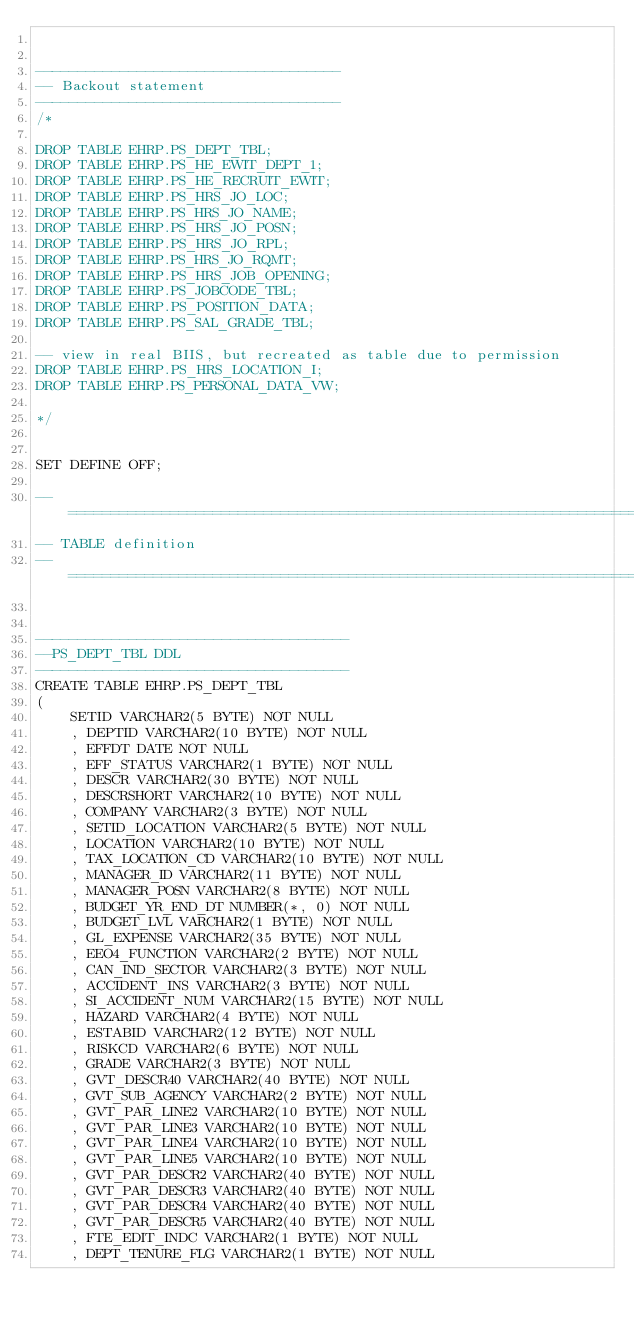<code> <loc_0><loc_0><loc_500><loc_500><_SQL_>

------------------------------------
-- Backout statement
------------------------------------
/*

DROP TABLE EHRP.PS_DEPT_TBL;
DROP TABLE EHRP.PS_HE_EWIT_DEPT_1;
DROP TABLE EHRP.PS_HE_RECRUIT_EWIT;
DROP TABLE EHRP.PS_HRS_JO_LOC;
DROP TABLE EHRP.PS_HRS_JO_NAME;
DROP TABLE EHRP.PS_HRS_JO_POSN;
DROP TABLE EHRP.PS_HRS_JO_RPL;
DROP TABLE EHRP.PS_HRS_JO_RQMT;
DROP TABLE EHRP.PS_HRS_JOB_OPENING;
DROP TABLE EHRP.PS_JOBCODE_TBL;
DROP TABLE EHRP.PS_POSITION_DATA;
DROP TABLE EHRP.PS_SAL_GRADE_TBL;

-- view in real BIIS, but recreated as table due to permission
DROP TABLE EHRP.PS_HRS_LOCATION_I;
DROP TABLE EHRP.PS_PERSONAL_DATA_VW;

*/


SET DEFINE OFF;

--=============================================================================
-- TABLE definition
--=============================================================================


-------------------------------------
--PS_DEPT_TBL DDL
-------------------------------------
CREATE TABLE EHRP.PS_DEPT_TBL 
(
	SETID VARCHAR2(5 BYTE) NOT NULL 
	, DEPTID VARCHAR2(10 BYTE) NOT NULL 
	, EFFDT DATE NOT NULL 
	, EFF_STATUS VARCHAR2(1 BYTE) NOT NULL 
	, DESCR VARCHAR2(30 BYTE) NOT NULL 
	, DESCRSHORT VARCHAR2(10 BYTE) NOT NULL 
	, COMPANY VARCHAR2(3 BYTE) NOT NULL 
	, SETID_LOCATION VARCHAR2(5 BYTE) NOT NULL 
	, LOCATION VARCHAR2(10 BYTE) NOT NULL 
	, TAX_LOCATION_CD VARCHAR2(10 BYTE) NOT NULL 
	, MANAGER_ID VARCHAR2(11 BYTE) NOT NULL 
	, MANAGER_POSN VARCHAR2(8 BYTE) NOT NULL 
	, BUDGET_YR_END_DT NUMBER(*, 0) NOT NULL 
	, BUDGET_LVL VARCHAR2(1 BYTE) NOT NULL 
	, GL_EXPENSE VARCHAR2(35 BYTE) NOT NULL 
	, EEO4_FUNCTION VARCHAR2(2 BYTE) NOT NULL 
	, CAN_IND_SECTOR VARCHAR2(3 BYTE) NOT NULL 
	, ACCIDENT_INS VARCHAR2(3 BYTE) NOT NULL 
	, SI_ACCIDENT_NUM VARCHAR2(15 BYTE) NOT NULL 
	, HAZARD VARCHAR2(4 BYTE) NOT NULL 
	, ESTABID VARCHAR2(12 BYTE) NOT NULL 
	, RISKCD VARCHAR2(6 BYTE) NOT NULL 
	, GRADE VARCHAR2(3 BYTE) NOT NULL 
	, GVT_DESCR40 VARCHAR2(40 BYTE) NOT NULL 
	, GVT_SUB_AGENCY VARCHAR2(2 BYTE) NOT NULL 
	, GVT_PAR_LINE2 VARCHAR2(10 BYTE) NOT NULL 
	, GVT_PAR_LINE3 VARCHAR2(10 BYTE) NOT NULL 
	, GVT_PAR_LINE4 VARCHAR2(10 BYTE) NOT NULL 
	, GVT_PAR_LINE5 VARCHAR2(10 BYTE) NOT NULL 
	, GVT_PAR_DESCR2 VARCHAR2(40 BYTE) NOT NULL 
	, GVT_PAR_DESCR3 VARCHAR2(40 BYTE) NOT NULL 
	, GVT_PAR_DESCR4 VARCHAR2(40 BYTE) NOT NULL 
	, GVT_PAR_DESCR5 VARCHAR2(40 BYTE) NOT NULL 
	, FTE_EDIT_INDC VARCHAR2(1 BYTE) NOT NULL 
	, DEPT_TENURE_FLG VARCHAR2(1 BYTE) NOT NULL </code> 